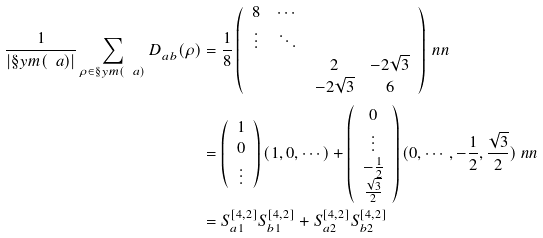<formula> <loc_0><loc_0><loc_500><loc_500>\frac { 1 } { | \S y m ( \ a ) | } \sum _ { \rho \in \S y m ( \ a ) } D ^ { \L } _ { a b } ( \rho ) & = \frac { 1 } { 8 } \left ( \begin{array} { c c c c } 8 & \cdots & & \\ \vdots & \ddots & & \\ & & 2 & - 2 \sqrt { 3 } \\ & & - 2 \sqrt { 3 } & 6 \end{array} \right ) \ n n \\ & = \left ( \begin{array} { c } 1 \\ 0 \\ \vdots \end{array} \right ) ( 1 , 0 , \cdots ) + \left ( \begin{array} { c } 0 \\ \vdots \\ - \frac { 1 } { 2 } \\ \frac { \sqrt { 3 } } { 2 } \end{array} \right ) ( 0 , \cdots , - \frac { 1 } { 2 } , \frac { \sqrt { 3 } } { 2 } ) \ n n \\ & = S ^ { [ 4 , 2 ] } _ { a 1 } S ^ { [ 4 , 2 ] } _ { b 1 } + S ^ { [ 4 , 2 ] } _ { a 2 } S ^ { [ 4 , 2 ] } _ { b 2 }</formula> 